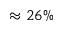Convert formula to latex. <formula><loc_0><loc_0><loc_500><loc_500>\approx 2 6 \%</formula> 